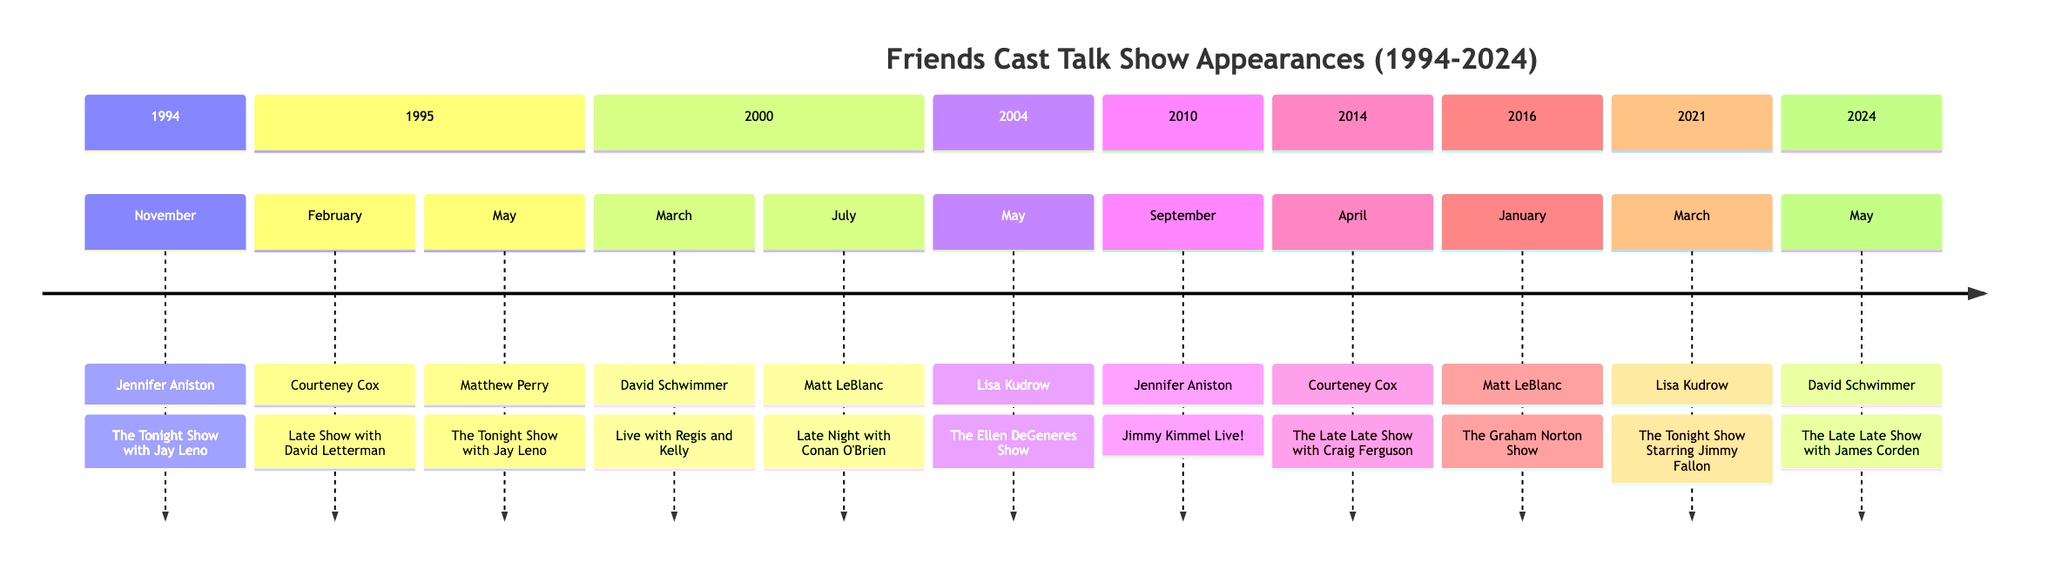What year did Jennifer Aniston first appear on a talk show? The data indicates that Jennifer Aniston first appeared on a talk show in November 1994.
Answer: 1994 How many times did Courteney Cox appear on talk shows between 1994 and 2024? Under the timeline, Courteney Cox appeared on talk shows in February 1995 and April 2014, totaling two appearances.
Answer: 2 Which show did Lisa Kudrow appear on in May 2004? According to the timeline, Lisa Kudrow appeared on "The Ellen DeGeneres Show" in May 2004.
Answer: The Ellen DeGeneres Show What month did David Schwimmer appear on "Live with Regis and Kelly"? The timeline specifies that David Schwimmer appeared on "Live with Regis and Kelly" in March 2000.
Answer: March Which two cast members appeared on talk shows in 2010? The data shows that Jennifer Aniston appeared in September and no other cast member is mentioned for 2010. Therefore, she is the only one from that year.
Answer: Jennifer Aniston What is the last year listed for a cast member's appearance on a talk show? The timeline ends with David Schwimmer's appearance on "The Late Late Show with James Corden" in May 2024, which is the most recent entry.
Answer: 2024 Which show aired the first talk show appearance by Matthew Perry? Matthew Perry's first appearance on a talk show was on "The Tonight Show with Jay Leno" in May 1995, as indicated in the timeline.
Answer: The Tonight Show with Jay Leno Who appeared on "The Graham Norton Show" and when? The timeline indicates that Matt LeBlanc was on "The Graham Norton Show" in January 2016.
Answer: Matt LeBlanc, January 2016 In what year did all six main cast members make their first appearances collectively? The timeline does not list any year where all six cast members are shown to appear; therefore, the first appearances of all characters coincide with various years but not collectively in one.
Answer: None 